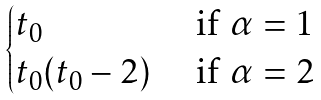Convert formula to latex. <formula><loc_0><loc_0><loc_500><loc_500>\begin{cases} t _ { 0 } & \text { if } \alpha = 1 \\ t _ { 0 } ( t _ { 0 } - 2 ) & \text { if } \alpha = 2 \\ \end{cases}</formula> 